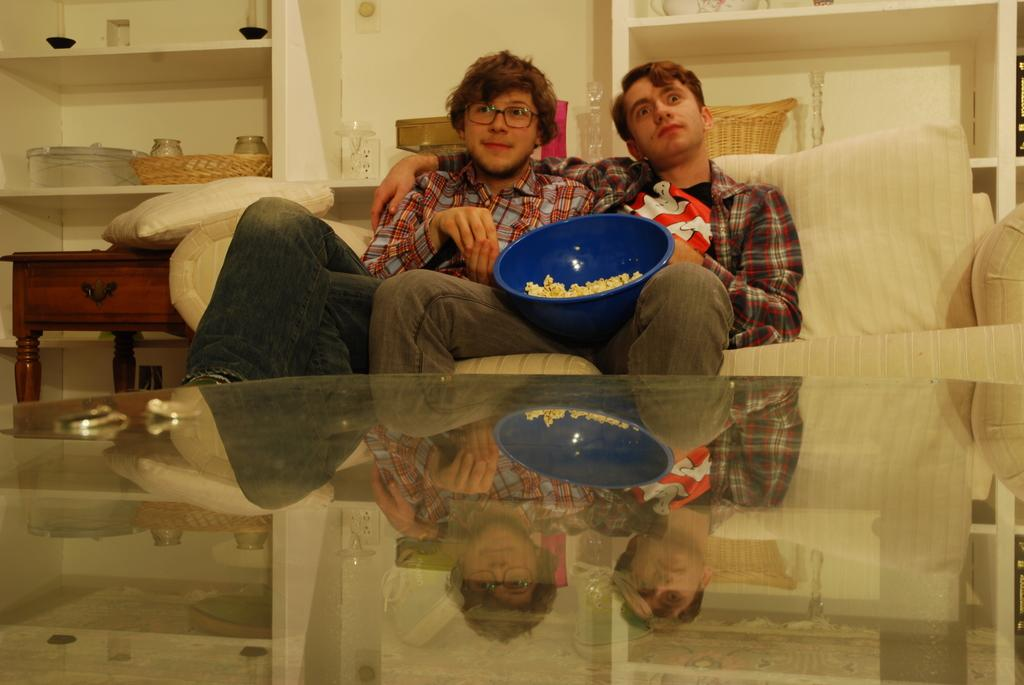How many people are in the image? There are two boys in the image. What are the boys holding in the image? The boys are holding a popcorn bowl. What type of furniture is visible in the image? There is a sofa and a teapoy in the image. What type of car are the boys driving in the image? There is no car present in the image; the boys are standing near a sofa and a teapoy. 